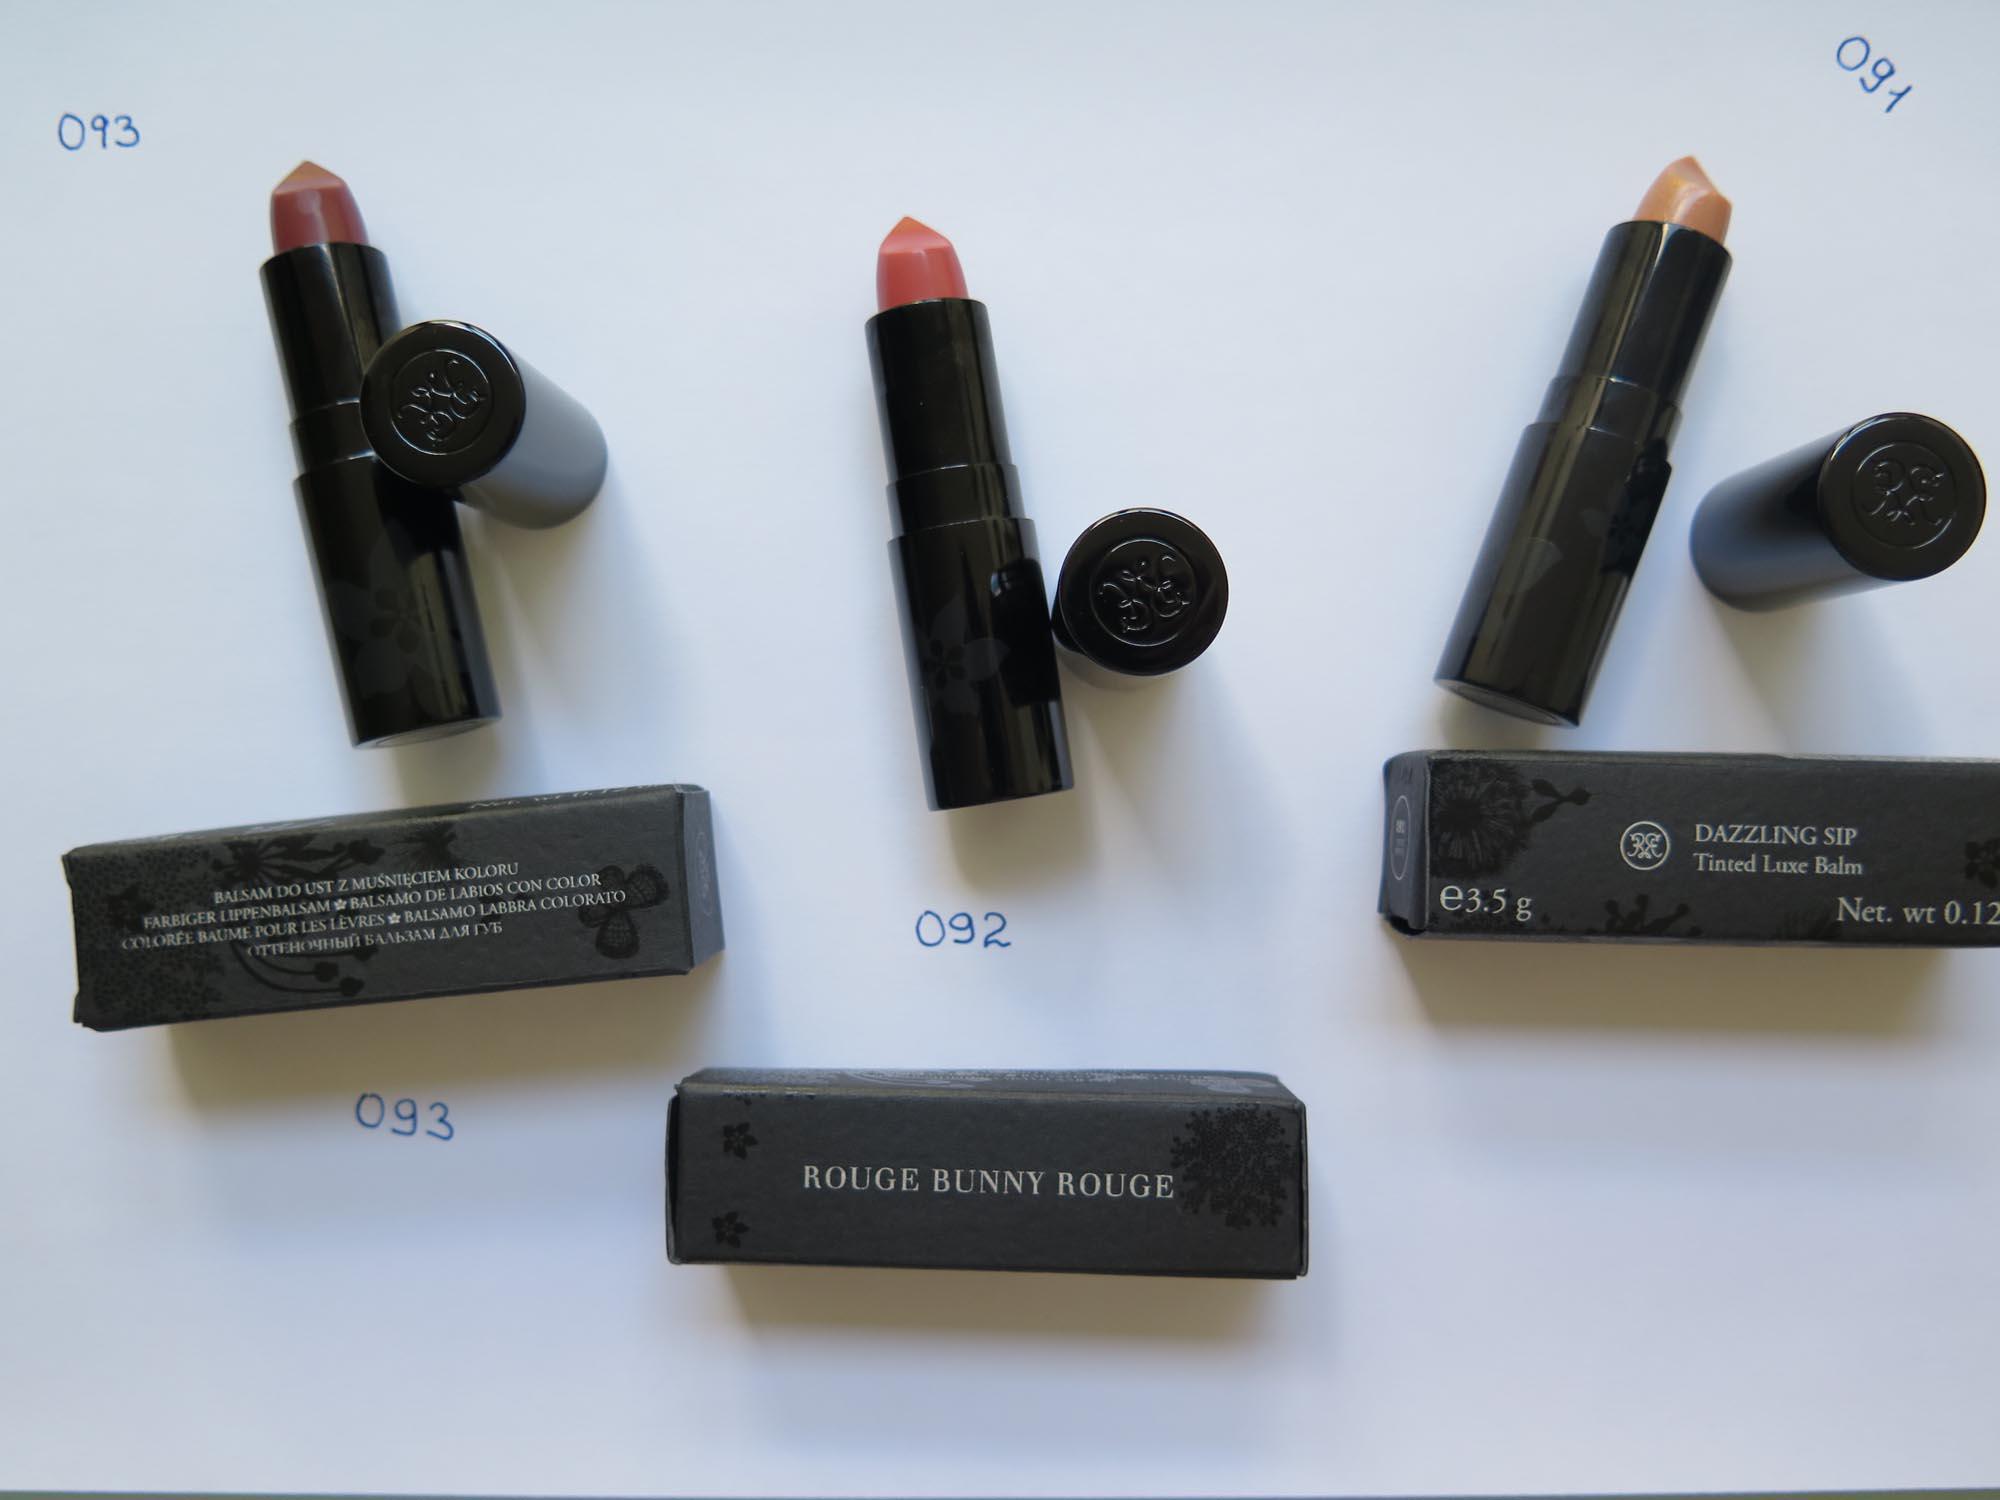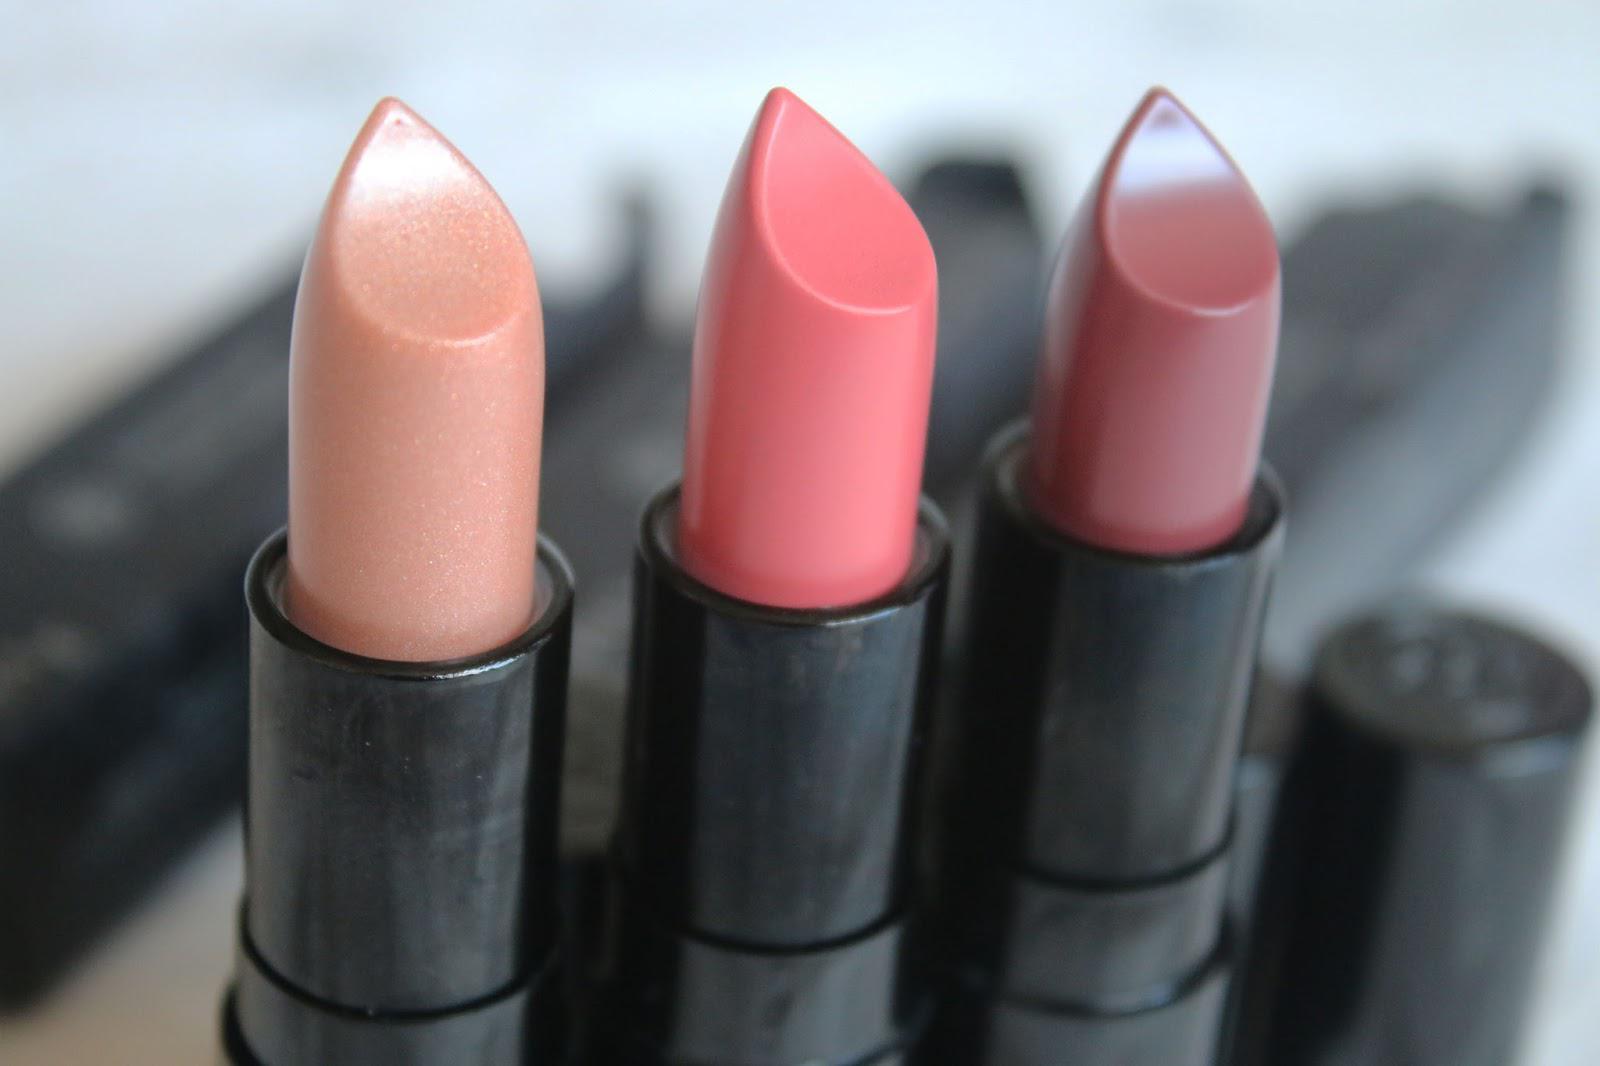The first image is the image on the left, the second image is the image on the right. For the images displayed, is the sentence "An image shows one upright tube lipstick next to its horizontal cap and a smear of color." factually correct? Answer yes or no. No. The first image is the image on the left, the second image is the image on the right. Given the left and right images, does the statement "The image on the right has a lipstick smudge on the left side of a single tube of lipstick." hold true? Answer yes or no. No. 